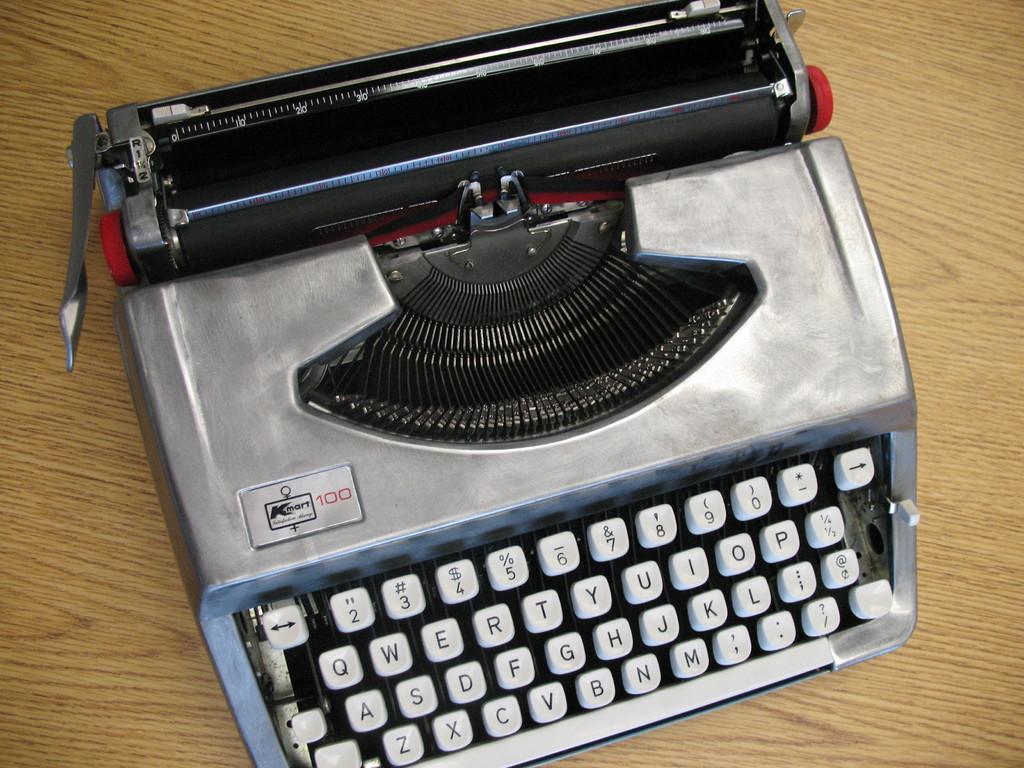Provide a one-sentence caption for the provided image. A vintage typewriter sports the name Kmart 100 in the corner. 